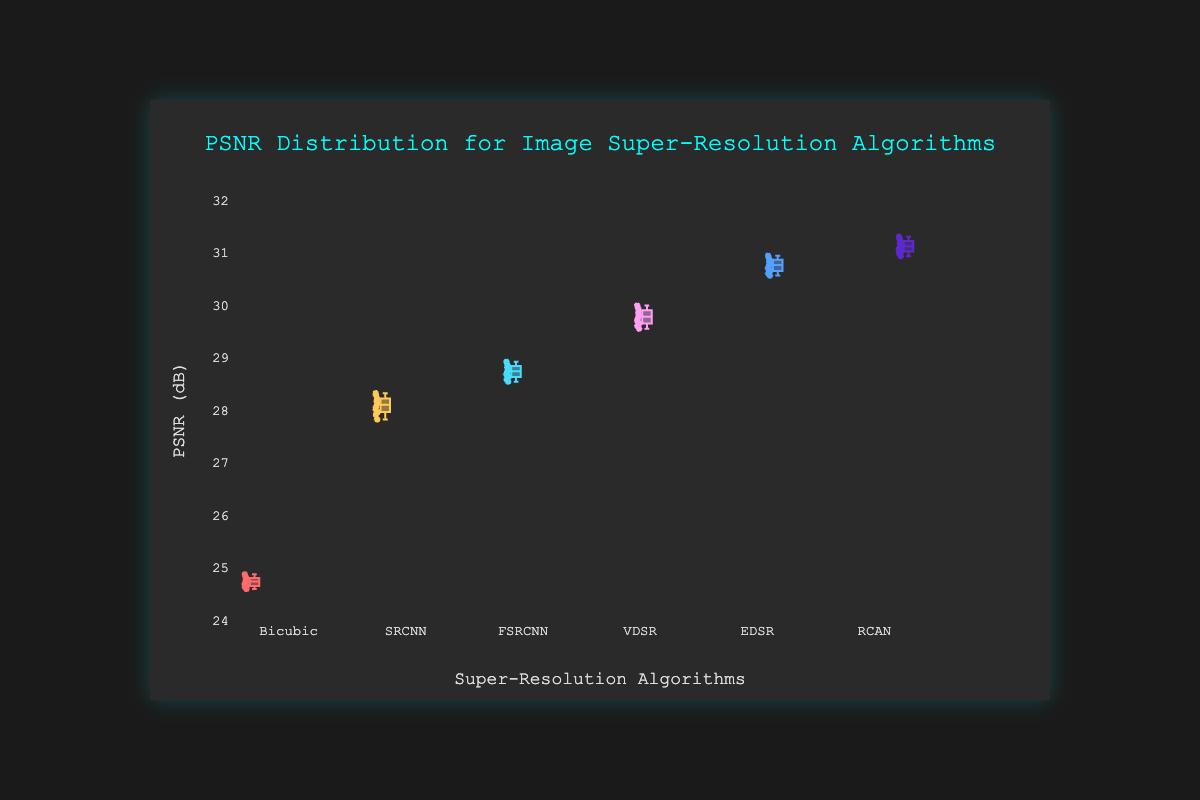What is the title of the plot? The title is located at the top of the plot and is used to describe the content presented.
Answer: PSNR Distribution for Image Super-Resolution Algorithms Which algorithm has the highest median PSNR value? By examining the central line inside each box which represents the median, identify the algorithm with the highest median.
Answer: RCAN How many different algorithms are compared in the plot? Count the number of distinct categories along the x-axis, each representing a different algorithm.
Answer: 6 What is the PSNR range for the Bicubic algorithm? Identify the minimum and maximum PSNR values within the Bicubic box plot, indicated by the box boundaries and whiskers.
Answer: 24.59 to 24.87 Which algorithm shows the largest interquartile range (IQR)? The IQR is the range between the first quartile (Q1) and third quartile (Q3). Compare the heights of the boxes to determine which one is the largest.
Answer: RCAN What is the lowest PSNR value for the VDSR algorithm? Look for the lowest point in the VDSR algorithm box plot, usually at the end of the lower whisker.
Answer: 29.55 Compare the median PSNR values of EDSR and FSRCNN. Which one is higher and by how much? Locate the medians inside the EDSR and FSRCNN box plots and subtract the FSRCNN median from the EDSR median to find the difference.
Answer: EDSR is higher by approximately 2.04 Between SRCNN and FSRCNN, which algorithm has a narrower PSNR distribution? A narrower distribution is indicated by a shorter box length. Compare the box lengths of SRCNN and FSRCNN.
Answer: SRCNN What is the PSNR value at the upper whisker for the EDSR algorithm? The upper whisker extends to the highest datum within 1.5 IQR of the upper quartile (Q3). Identify this value for EDSR.
Answer: 30.94 